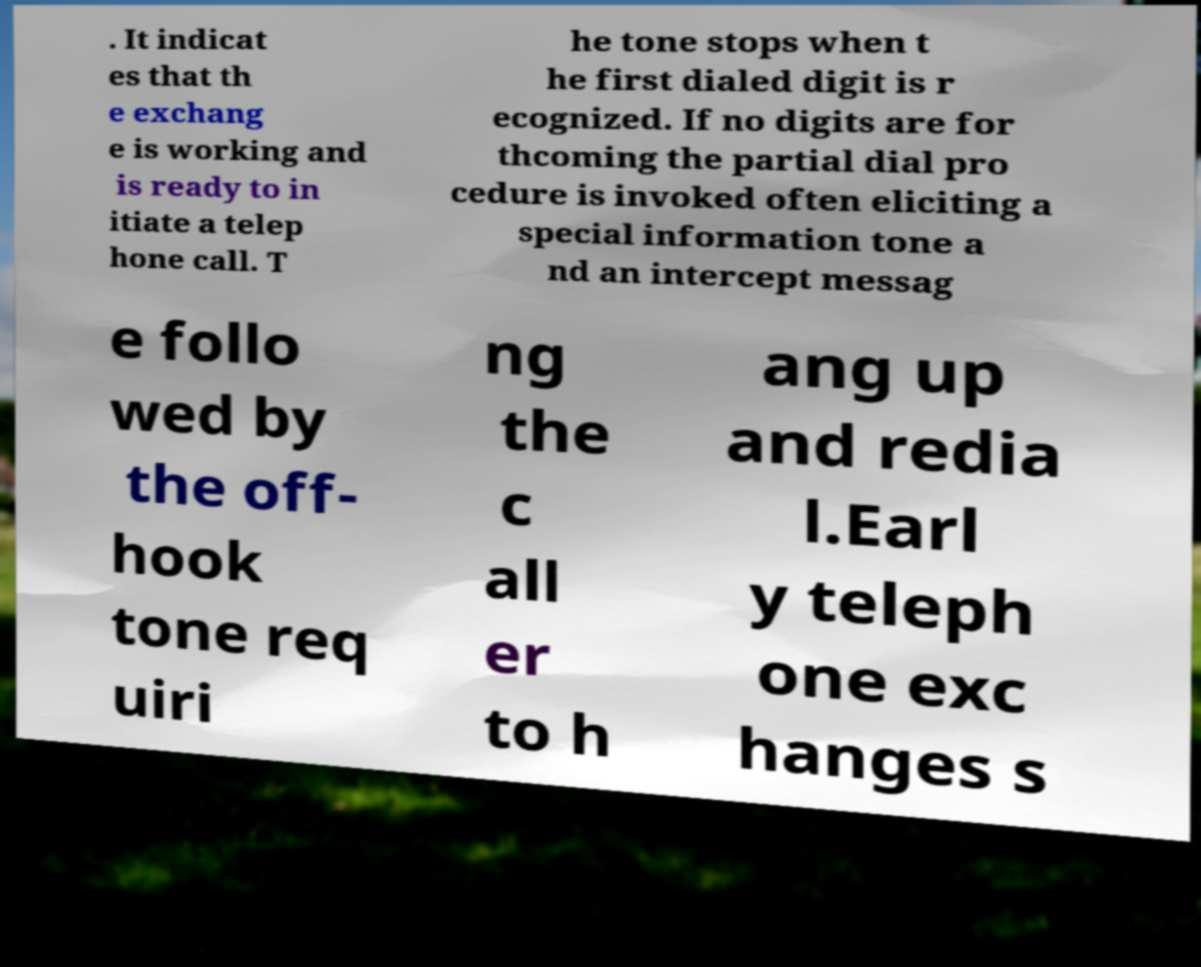Can you accurately transcribe the text from the provided image for me? . It indicat es that th e exchang e is working and is ready to in itiate a telep hone call. T he tone stops when t he first dialed digit is r ecognized. If no digits are for thcoming the partial dial pro cedure is invoked often eliciting a special information tone a nd an intercept messag e follo wed by the off- hook tone req uiri ng the c all er to h ang up and redia l.Earl y teleph one exc hanges s 